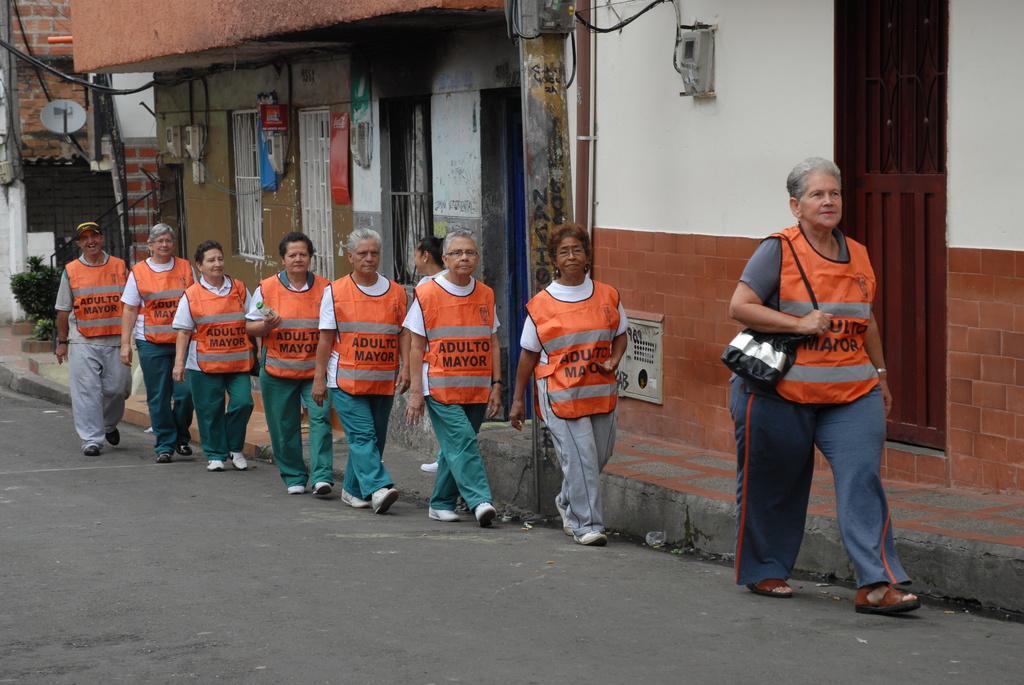Could you give a brief overview of what you see in this image? In this image there are people standing in a queue on the road. The people wearing some orange color coat. There is a building on the background. 